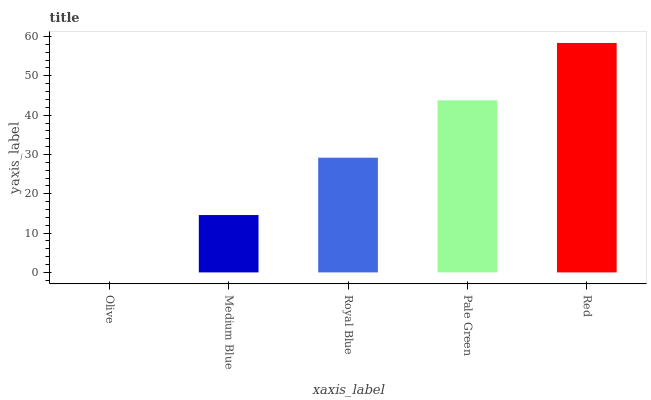Is Medium Blue the minimum?
Answer yes or no. No. Is Medium Blue the maximum?
Answer yes or no. No. Is Medium Blue greater than Olive?
Answer yes or no. Yes. Is Olive less than Medium Blue?
Answer yes or no. Yes. Is Olive greater than Medium Blue?
Answer yes or no. No. Is Medium Blue less than Olive?
Answer yes or no. No. Is Royal Blue the high median?
Answer yes or no. Yes. Is Royal Blue the low median?
Answer yes or no. Yes. Is Olive the high median?
Answer yes or no. No. Is Olive the low median?
Answer yes or no. No. 